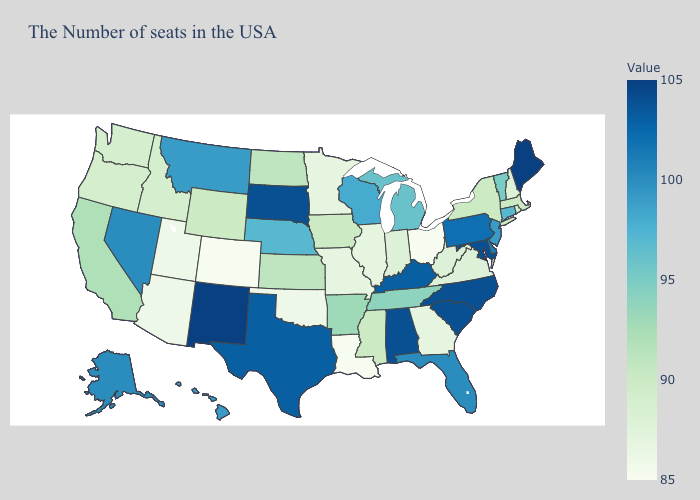Does Wyoming have a lower value than Illinois?
Give a very brief answer. No. Which states have the lowest value in the South?
Be succinct. Louisiana. Among the states that border Wisconsin , which have the highest value?
Write a very short answer. Michigan. Does Connecticut have the highest value in the Northeast?
Short answer required. No. 